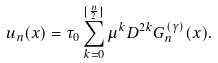<formula> <loc_0><loc_0><loc_500><loc_500>u _ { n } ( x ) = \tau _ { 0 } \sum _ { k = 0 } ^ { [ \frac { n } { 2 } ] } \mu ^ { k } D ^ { 2 k } G _ { n } ^ { ( \gamma ) } ( x ) .</formula> 